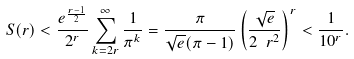<formula> <loc_0><loc_0><loc_500><loc_500>S ( r ) < \frac { e ^ { \frac { r - 1 } { 2 } } } { 2 ^ { r } } \sum _ { k = 2 r } ^ { \infty } \frac { 1 } { \pi ^ { k } } = \frac { \pi } { \sqrt { e } ( \pi - 1 ) } \left ( \frac { \sqrt { e } } { 2 \ r ^ { 2 } } \right ) ^ { r } < \frac { 1 } { 1 0 ^ { r } } .</formula> 